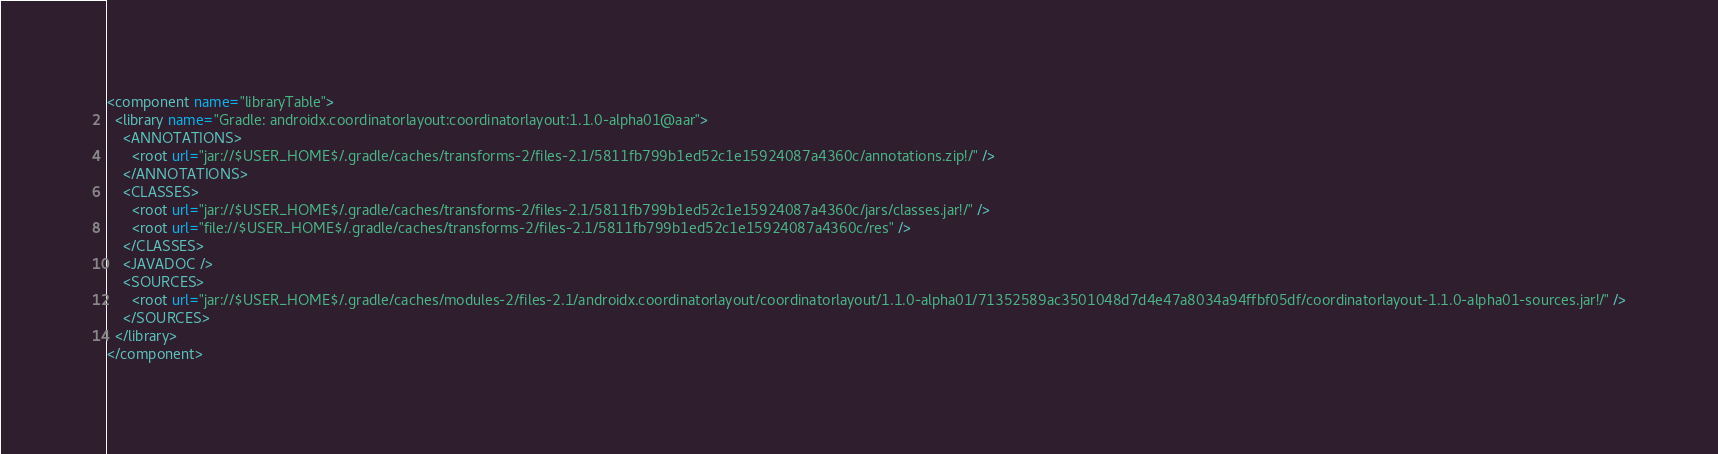Convert code to text. <code><loc_0><loc_0><loc_500><loc_500><_XML_><component name="libraryTable">
  <library name="Gradle: androidx.coordinatorlayout:coordinatorlayout:1.1.0-alpha01@aar">
    <ANNOTATIONS>
      <root url="jar://$USER_HOME$/.gradle/caches/transforms-2/files-2.1/5811fb799b1ed52c1e15924087a4360c/annotations.zip!/" />
    </ANNOTATIONS>
    <CLASSES>
      <root url="jar://$USER_HOME$/.gradle/caches/transforms-2/files-2.1/5811fb799b1ed52c1e15924087a4360c/jars/classes.jar!/" />
      <root url="file://$USER_HOME$/.gradle/caches/transforms-2/files-2.1/5811fb799b1ed52c1e15924087a4360c/res" />
    </CLASSES>
    <JAVADOC />
    <SOURCES>
      <root url="jar://$USER_HOME$/.gradle/caches/modules-2/files-2.1/androidx.coordinatorlayout/coordinatorlayout/1.1.0-alpha01/71352589ac3501048d7d4e47a8034a94ffbf05df/coordinatorlayout-1.1.0-alpha01-sources.jar!/" />
    </SOURCES>
  </library>
</component></code> 